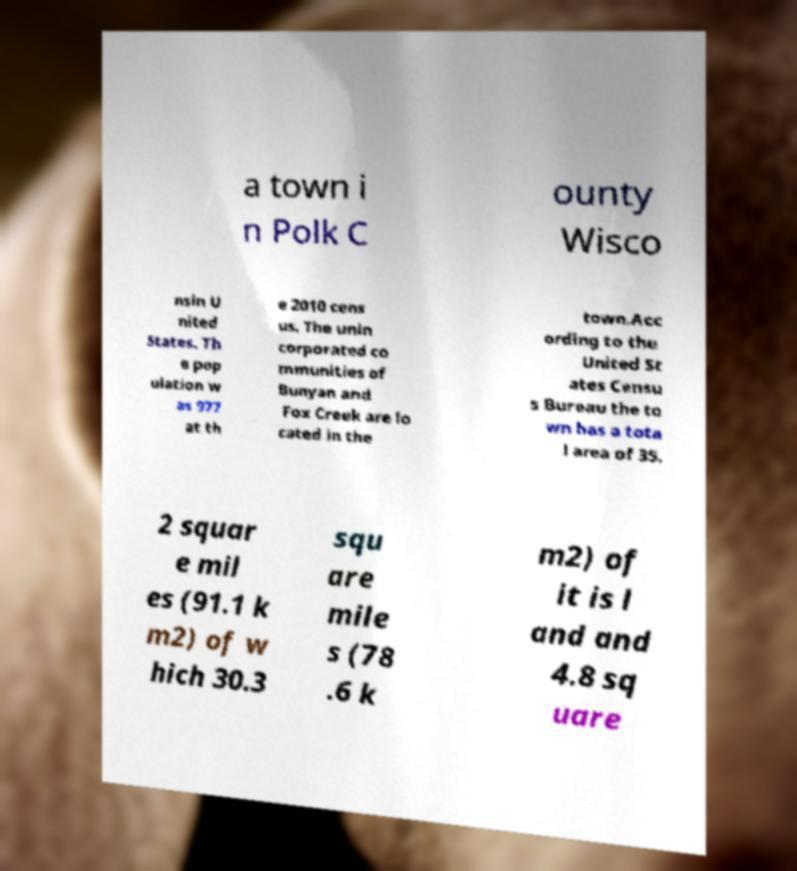What messages or text are displayed in this image? I need them in a readable, typed format. a town i n Polk C ounty Wisco nsin U nited States. Th e pop ulation w as 977 at th e 2010 cens us. The unin corporated co mmunities of Bunyan and Fox Creek are lo cated in the town.Acc ording to the United St ates Censu s Bureau the to wn has a tota l area of 35. 2 squar e mil es (91.1 k m2) of w hich 30.3 squ are mile s (78 .6 k m2) of it is l and and 4.8 sq uare 